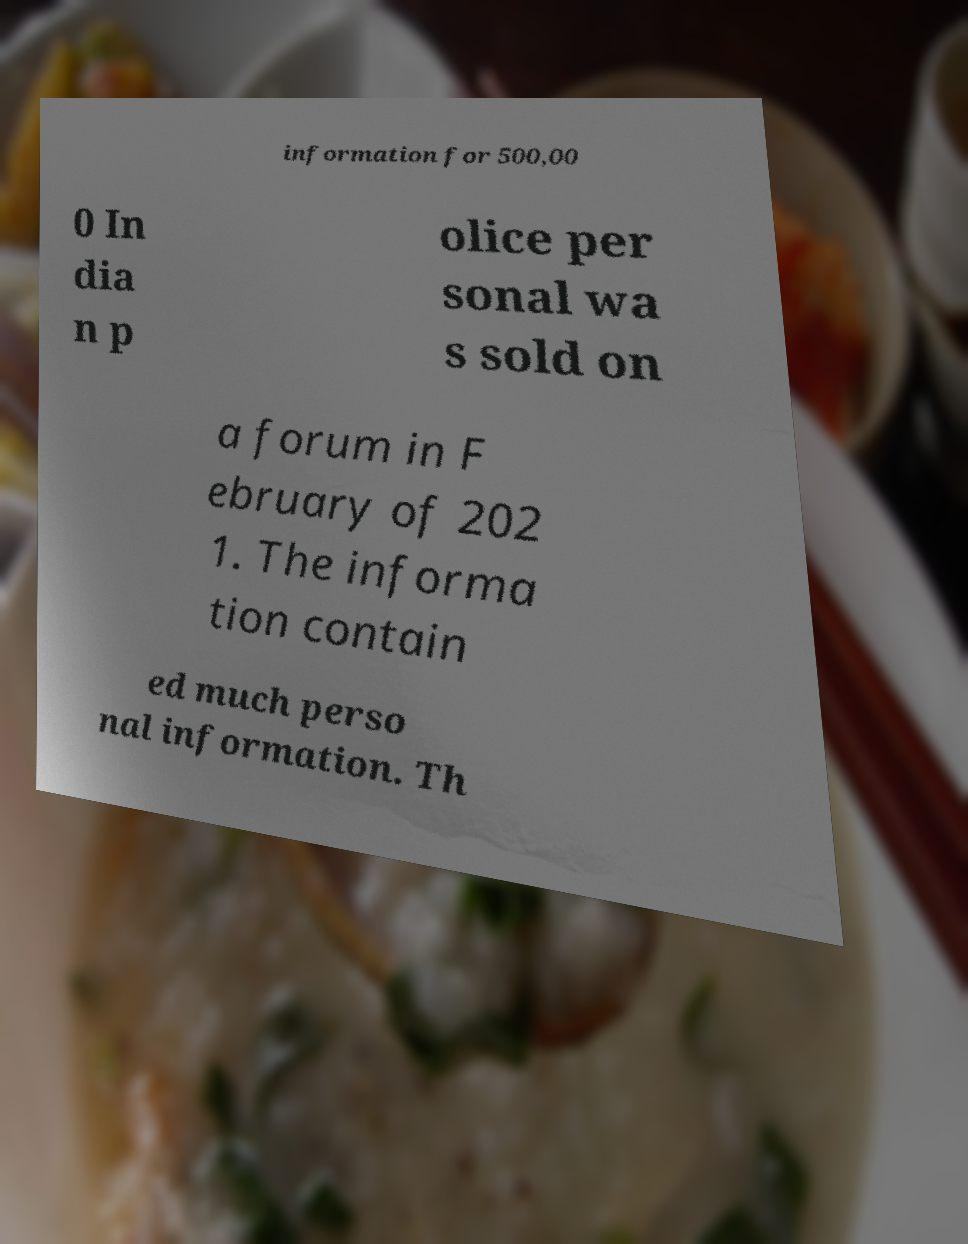What messages or text are displayed in this image? I need them in a readable, typed format. information for 500,00 0 In dia n p olice per sonal wa s sold on a forum in F ebruary of 202 1. The informa tion contain ed much perso nal information. Th 